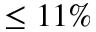<formula> <loc_0><loc_0><loc_500><loc_500>\leq 1 1 \%</formula> 